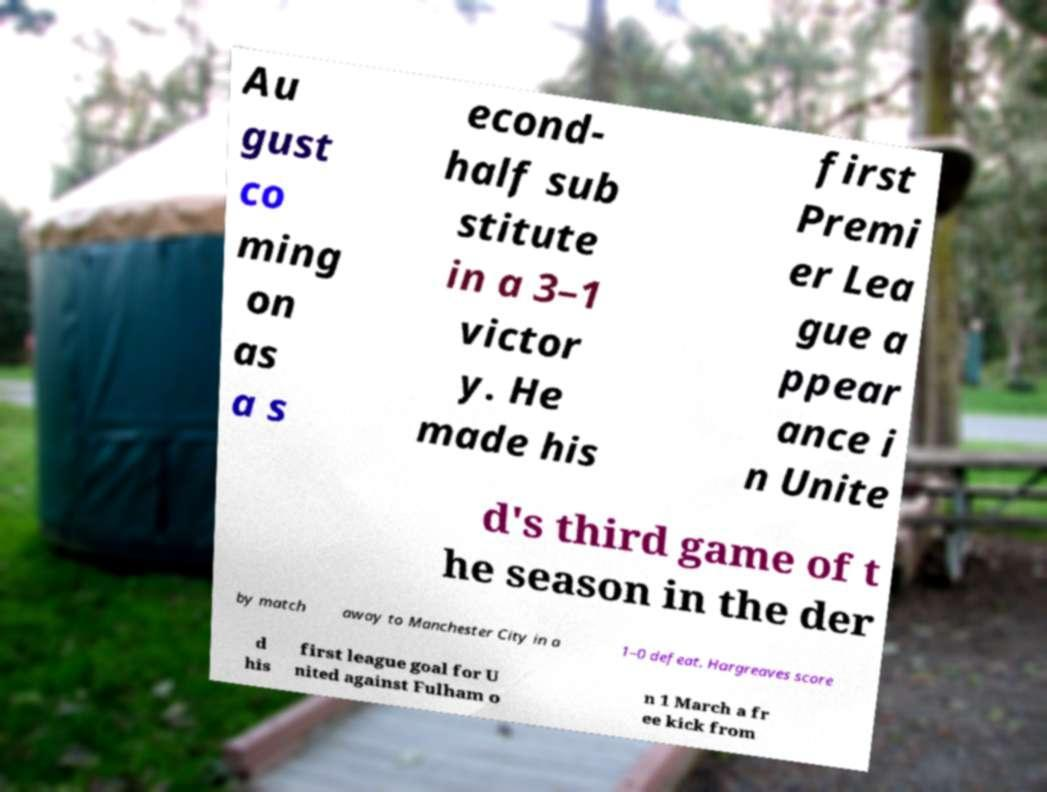Could you extract and type out the text from this image? Au gust co ming on as a s econd- half sub stitute in a 3–1 victor y. He made his first Premi er Lea gue a ppear ance i n Unite d's third game of t he season in the der by match away to Manchester City in a 1–0 defeat. Hargreaves score d his first league goal for U nited against Fulham o n 1 March a fr ee kick from 